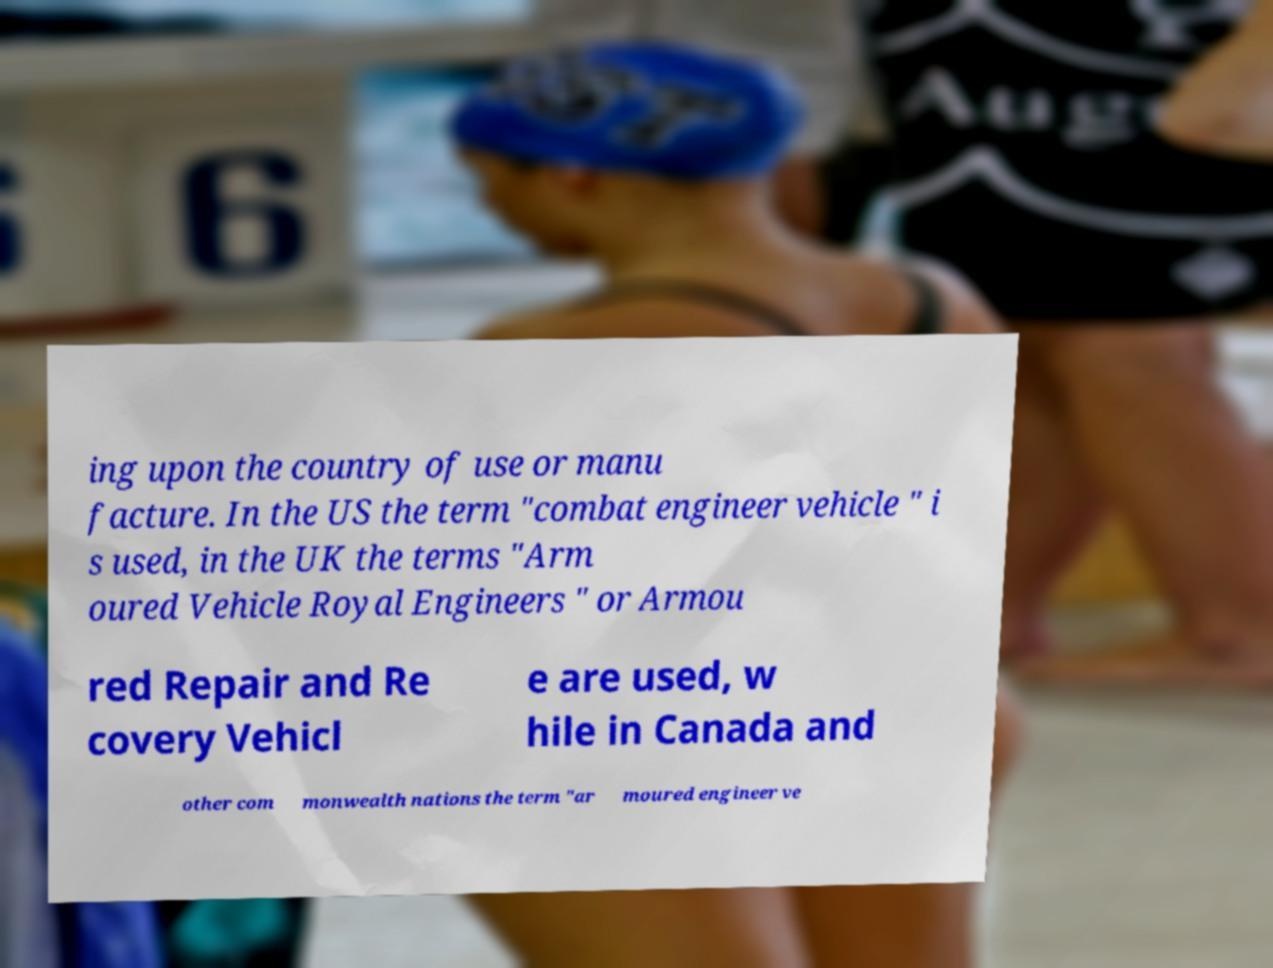Could you extract and type out the text from this image? ing upon the country of use or manu facture. In the US the term "combat engineer vehicle " i s used, in the UK the terms "Arm oured Vehicle Royal Engineers " or Armou red Repair and Re covery Vehicl e are used, w hile in Canada and other com monwealth nations the term "ar moured engineer ve 